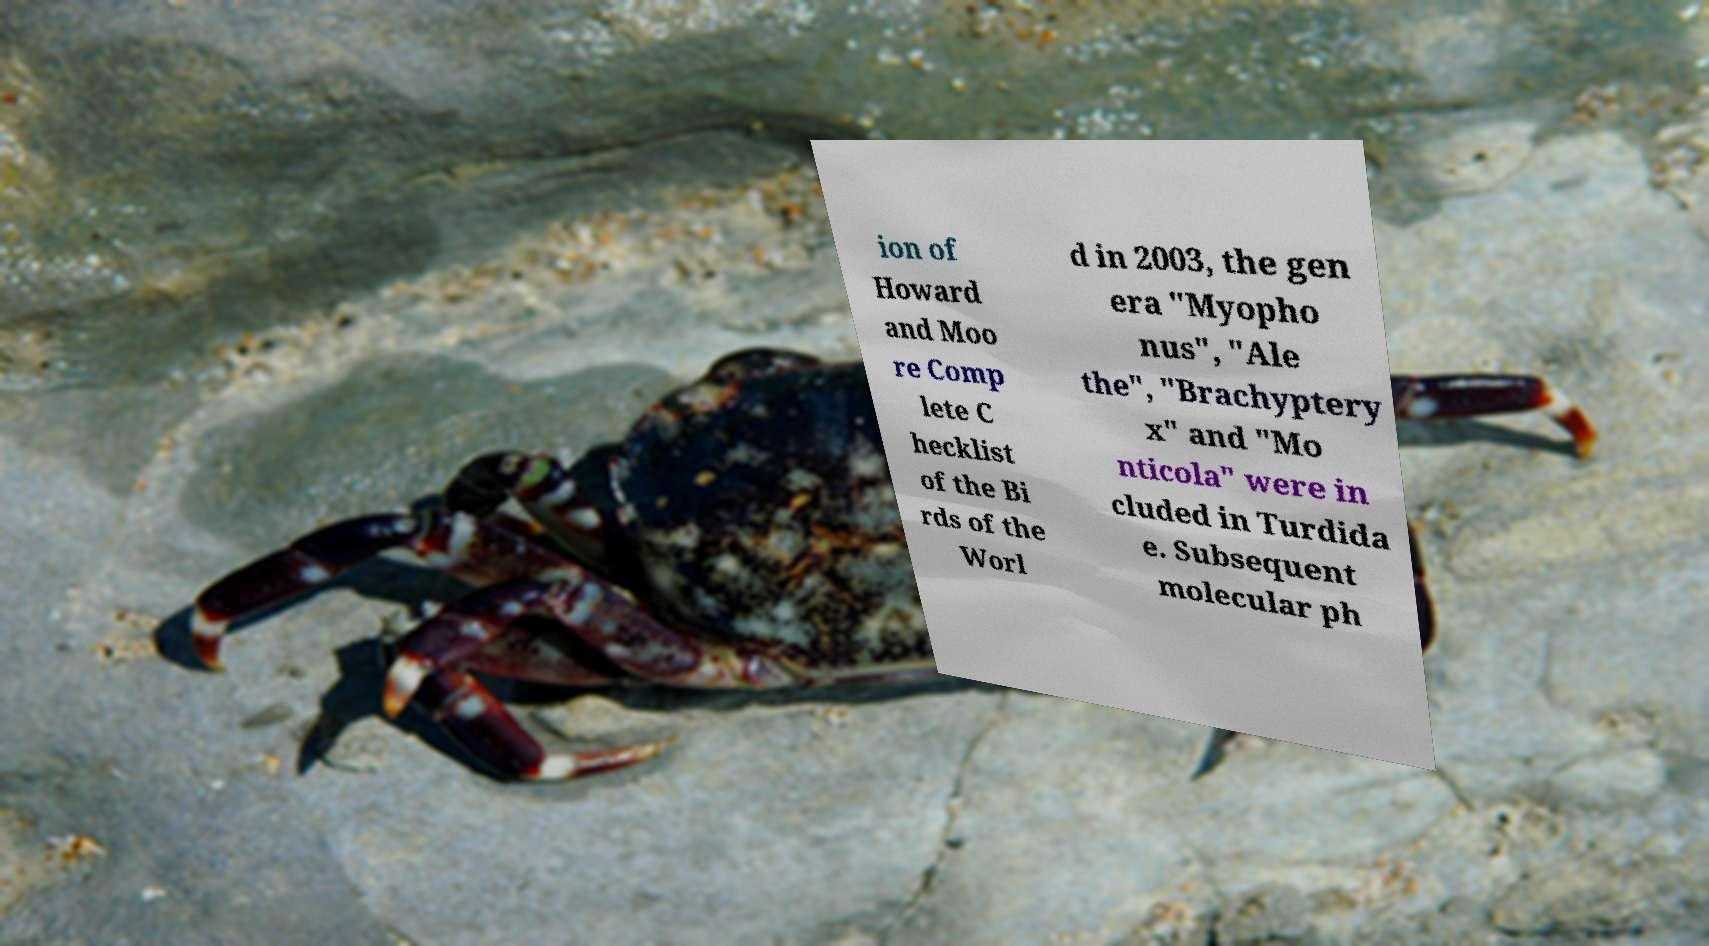Can you accurately transcribe the text from the provided image for me? ion of Howard and Moo re Comp lete C hecklist of the Bi rds of the Worl d in 2003, the gen era "Myopho nus", "Ale the", "Brachyptery x" and "Mo nticola" were in cluded in Turdida e. Subsequent molecular ph 